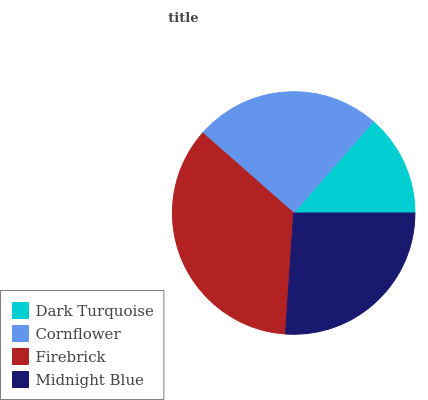Is Dark Turquoise the minimum?
Answer yes or no. Yes. Is Firebrick the maximum?
Answer yes or no. Yes. Is Cornflower the minimum?
Answer yes or no. No. Is Cornflower the maximum?
Answer yes or no. No. Is Cornflower greater than Dark Turquoise?
Answer yes or no. Yes. Is Dark Turquoise less than Cornflower?
Answer yes or no. Yes. Is Dark Turquoise greater than Cornflower?
Answer yes or no. No. Is Cornflower less than Dark Turquoise?
Answer yes or no. No. Is Midnight Blue the high median?
Answer yes or no. Yes. Is Cornflower the low median?
Answer yes or no. Yes. Is Firebrick the high median?
Answer yes or no. No. Is Firebrick the low median?
Answer yes or no. No. 